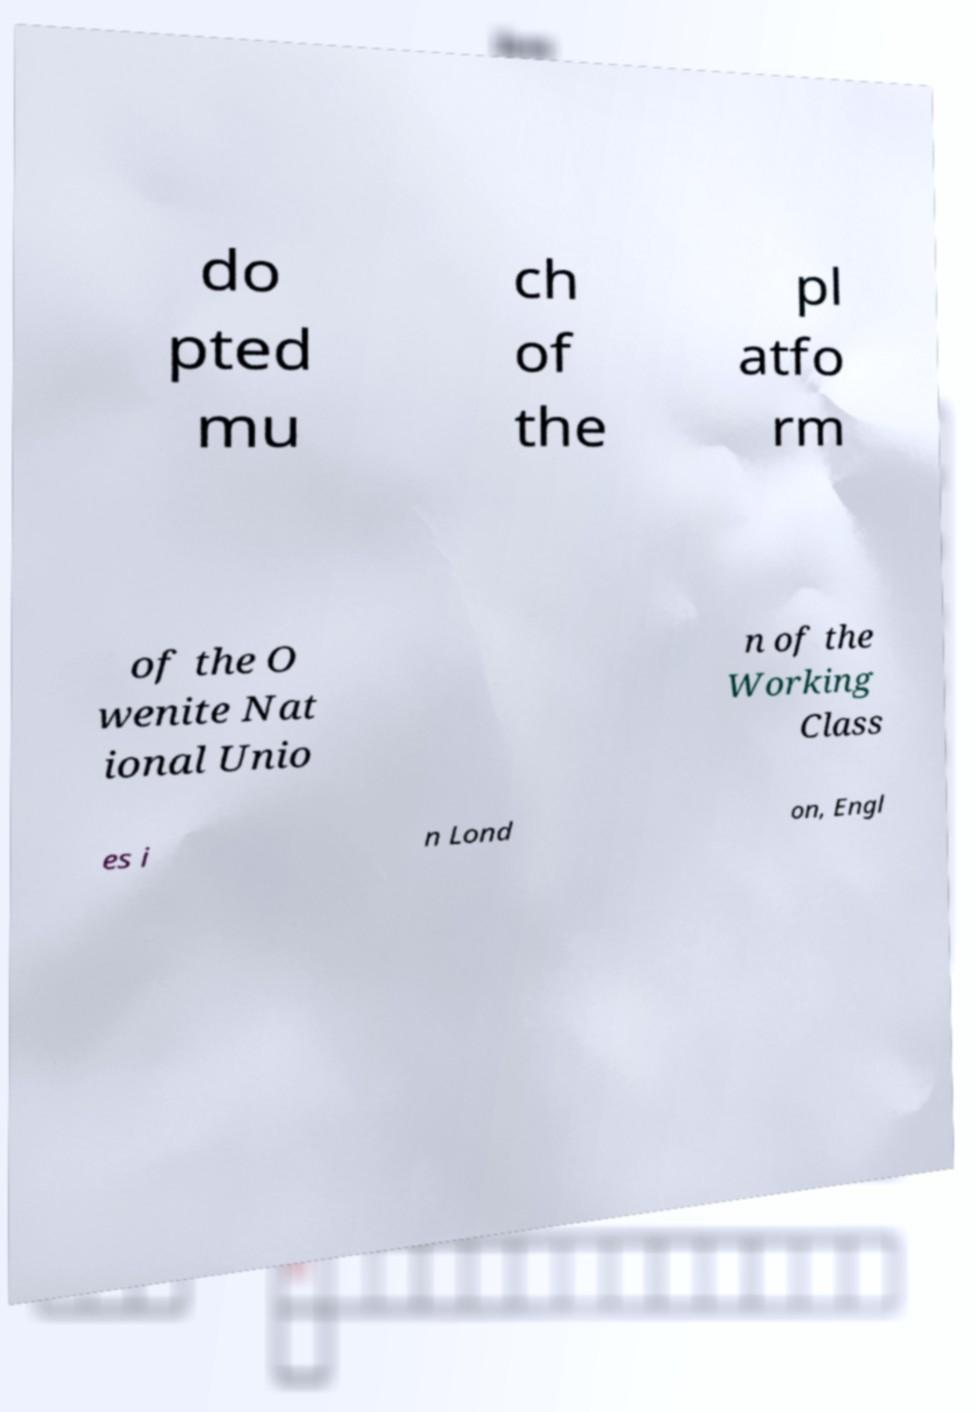For documentation purposes, I need the text within this image transcribed. Could you provide that? do pted mu ch of the pl atfo rm of the O wenite Nat ional Unio n of the Working Class es i n Lond on, Engl 